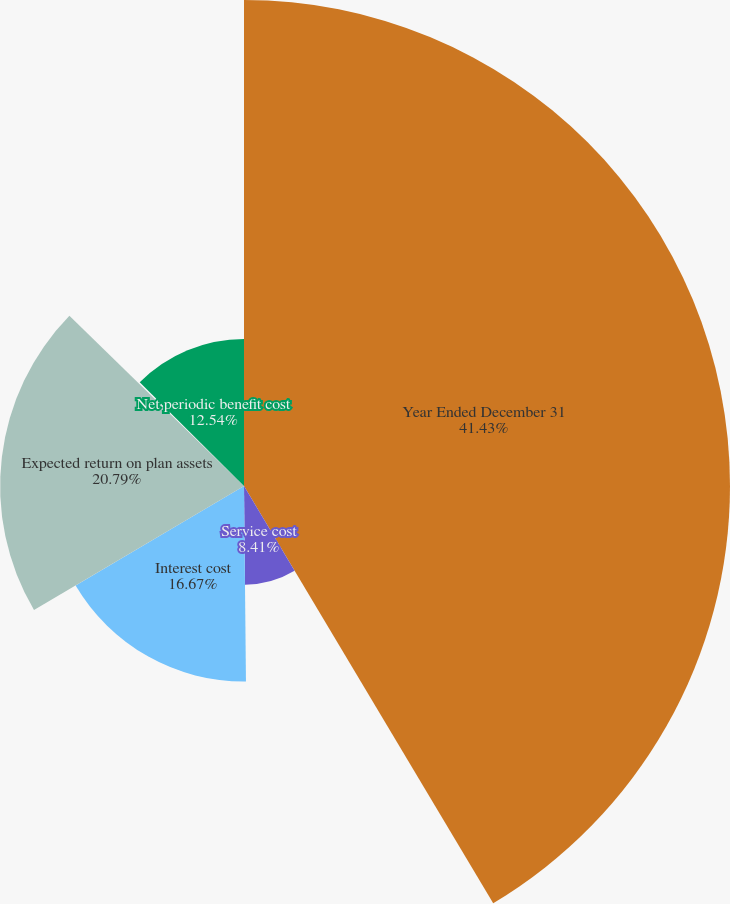<chart> <loc_0><loc_0><loc_500><loc_500><pie_chart><fcel>Year Ended December 31<fcel>Service cost<fcel>Interest cost<fcel>Expected return on plan assets<fcel>Amortization of unrecognized<fcel>Net periodic benefit cost<nl><fcel>41.43%<fcel>8.41%<fcel>16.67%<fcel>20.79%<fcel>0.16%<fcel>12.54%<nl></chart> 